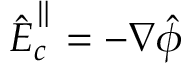Convert formula to latex. <formula><loc_0><loc_0><loc_500><loc_500>\hat { \boldsymbol E } _ { c } ^ { \| } = - \boldsymbol \nabla \hat { \phi }</formula> 